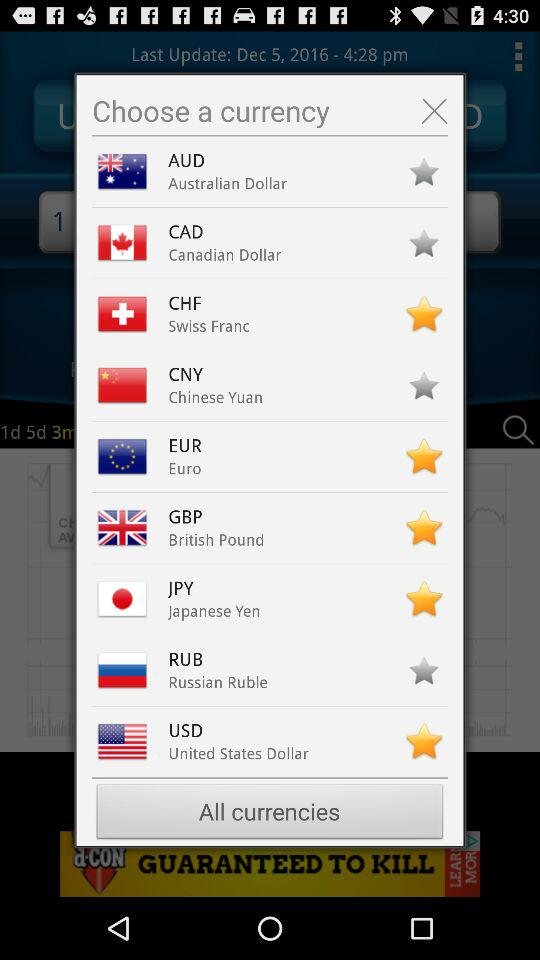Which currencies are selected as favorites? The selected currencies are CHF, EUR, GBP, JPY and USD. 